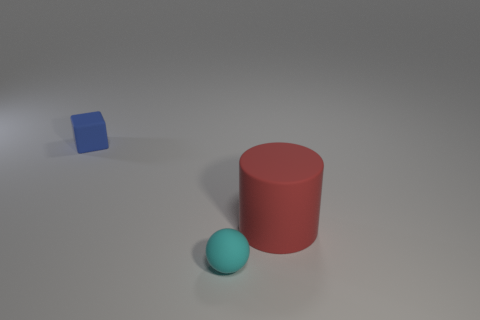Add 2 large yellow rubber cubes. How many objects exist? 5 Subtract all balls. How many objects are left? 2 Add 1 big things. How many big things exist? 2 Subtract 0 red cubes. How many objects are left? 3 Subtract all yellow matte cylinders. Subtract all big red cylinders. How many objects are left? 2 Add 1 big objects. How many big objects are left? 2 